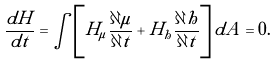Convert formula to latex. <formula><loc_0><loc_0><loc_500><loc_500>\frac { d H } { d t } = \int \left [ H _ { \mu } \frac { \partial \mu } { \partial t } + H _ { h } \frac { \partial h } { \partial t } \right ] d A = 0 .</formula> 